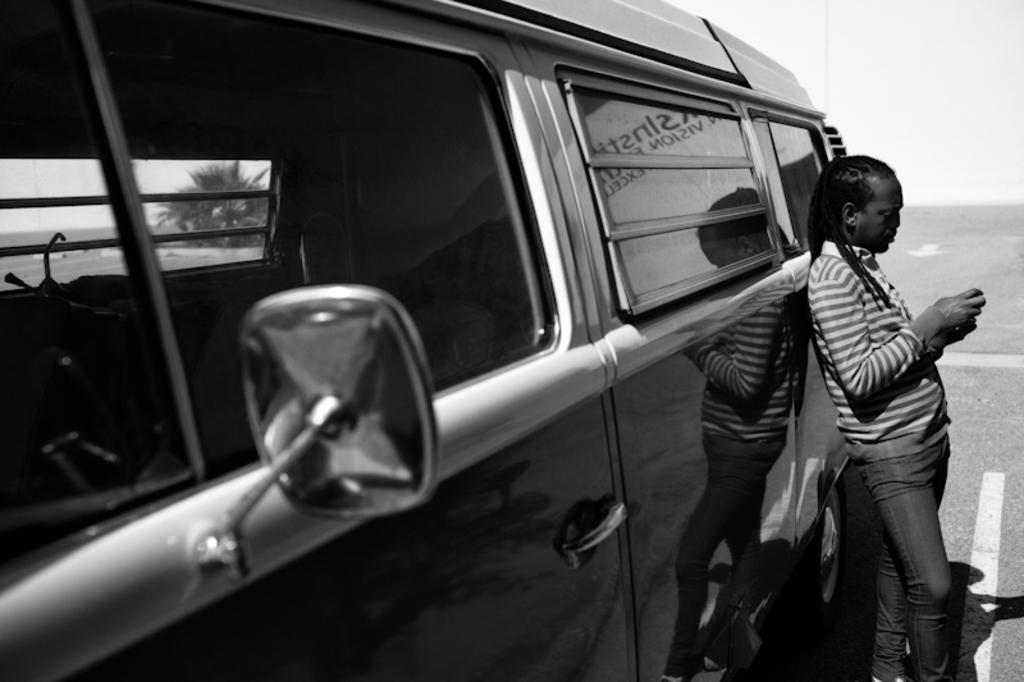What is the main subject of the image? There is a person standing in the image. What else can be seen in the image besides the person? There is a vehicle on the road in the image. Can you describe the vehicle's surroundings? A tree is visible through the window of the vehicle. What type of zipper can be seen on the person's clothing in the image? There is no mention of a zipper in the provided facts, and therefore it cannot be determined if one is present or not. 